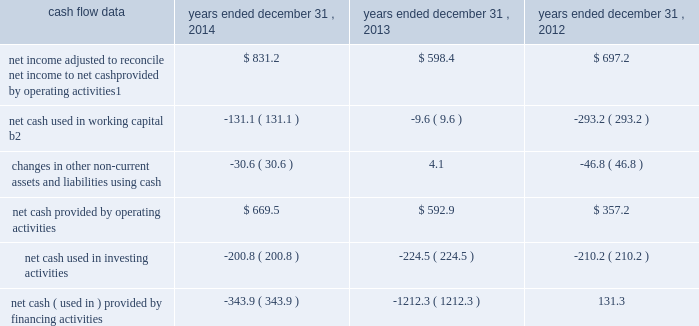Management 2019s discussion and analysis of financial condition and results of operations 2013 ( continued ) ( amounts in millions , except per share amounts ) corporate and other expenses increased slightly during 2013 by $ 3.5 to $ 140.8 compared to 2012 , primarily due to an increase in salaries and related expenses , mainly attributable to higher base salaries , benefits and temporary help , partially offset by lower severance expenses and a decrease in office and general expenses .
Liquidity and capital resources cash flow overview the tables summarize key financial data relating to our liquidity , capital resources and uses of capital. .
1 reflects net income adjusted primarily for depreciation and amortization of fixed assets and intangible assets , amortization of restricted stock and other non-cash compensation , non-cash ( gain ) loss related to early extinguishment of debt , and deferred income taxes .
2 reflects changes in accounts receivable , expenditures billable to clients , other current assets , accounts payable and accrued liabilities .
Operating activities net cash provided by operating activities during 2014 was $ 669.5 , which was an improvement of $ 76.6 as compared to 2013 , primarily as a result of an increase in net income , offset by an increase in working capital usage of $ 121.5 .
Due to the seasonality of our business , we typically generate cash from working capital in the second half of a year and use cash from working capital in the first half of a year , with the largest impacts in the first and fourth quarters .
Our net working capital usage in 2014 was impacted by our media businesses .
Net cash provided by operating activities during 2013 was $ 592.9 , which was an increase of $ 235.7 as compared to 2012 , primarily as a result of an improvement in working capital usage of $ 283.6 , offset by a decrease in net income .
The improvement in working capital in 2013 was impacted by our media businesses and an ongoing focus on working capital management at our agencies .
The timing of media buying on behalf of our clients affects our working capital and operating cash flow .
In most of our businesses , our agencies enter into commitments to pay production and media costs on behalf of clients .
To the extent possible we pay production and media charges after we have received funds from our clients .
The amounts involved substantially exceed our revenues and primarily affect the level of accounts receivable , expenditures billable to clients , accounts payable and accrued liabilities .
Our assets include both cash received and accounts receivable from clients for these pass-through arrangements , while our liabilities include amounts owed on behalf of clients to media and production suppliers .
Our accrued liabilities are also affected by the timing of certain other payments .
For example , while annual cash incentive awards are accrued throughout the year , they are generally paid during the first quarter of the subsequent year .
Investing activities net cash used in investing activities during 2014 primarily related to payments for capital expenditures and acquisitions .
Capital expenditures of $ 148.7 related primarily to computer hardware and software and leasehold improvements .
We made payments of $ 67.8 related to acquisitions completed during 2014 , net of cash acquired. .
What is the mathematical range of net income adjusted to reconcile net income to net cash provided by operating activities from 2012-2014? 
Computations: (831.2 - 598.4)
Answer: 232.8. 